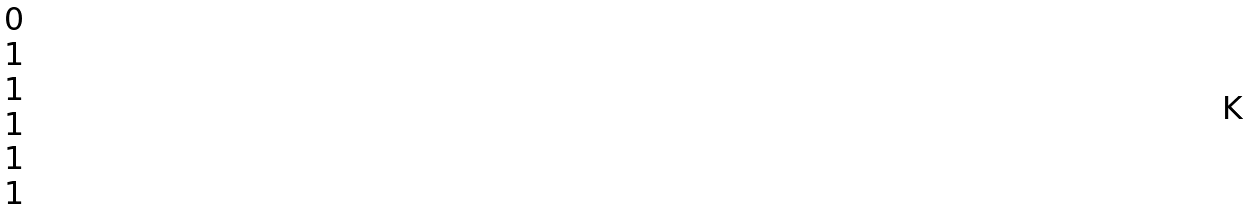<formula> <loc_0><loc_0><loc_500><loc_500>\begin{matrix} 0 \\ 1 \\ 1 \\ 1 \\ 1 \\ 1 \end{matrix}</formula> 